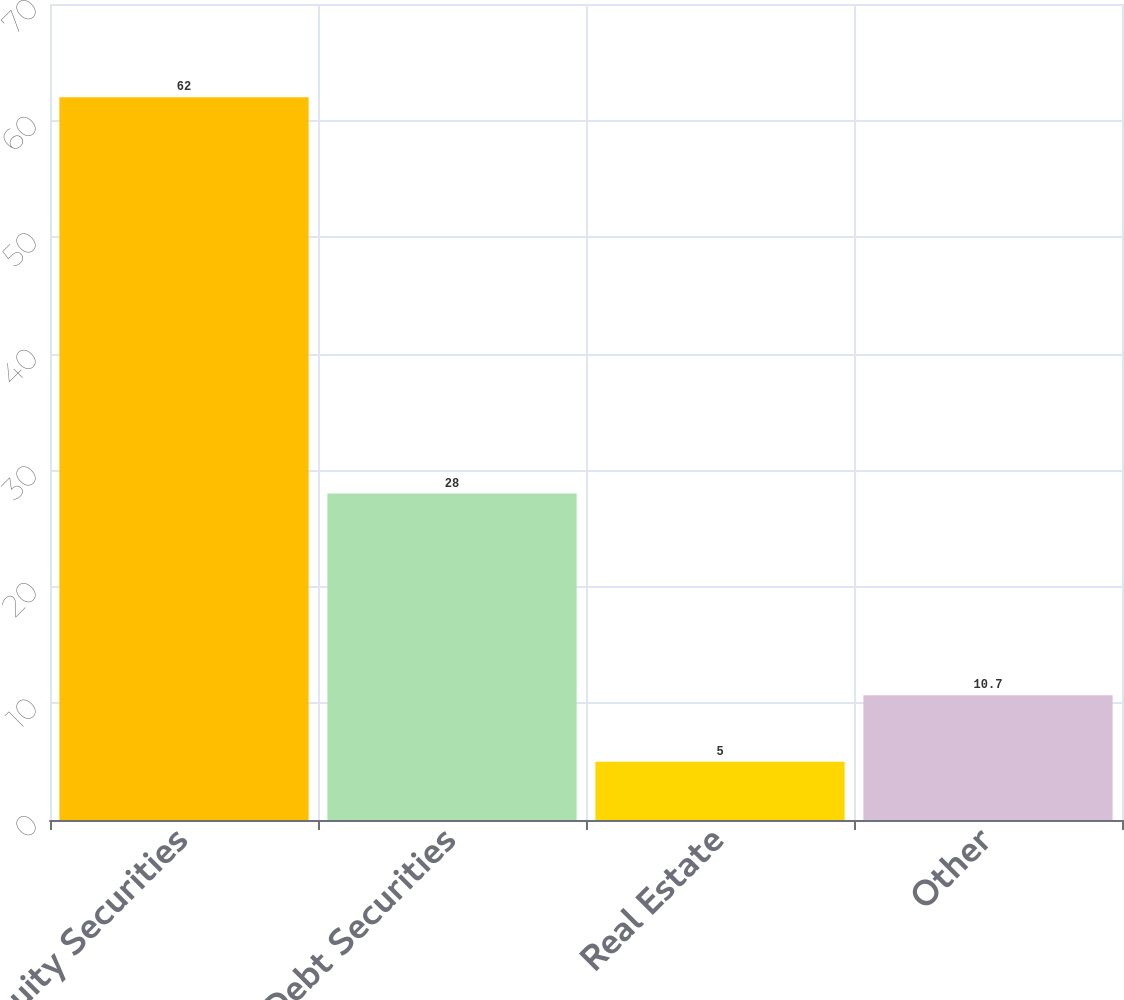Convert chart. <chart><loc_0><loc_0><loc_500><loc_500><bar_chart><fcel>Equity Securities<fcel>Debt Securities<fcel>Real Estate<fcel>Other<nl><fcel>62<fcel>28<fcel>5<fcel>10.7<nl></chart> 